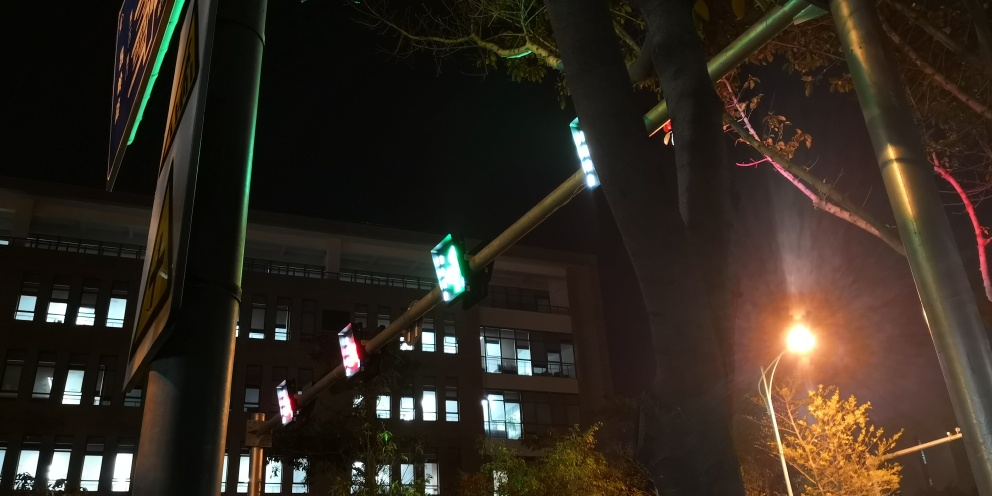Can you describe how the interplay of light and shadow contributes to the composition of this photograph? The interplay of light and shadow in this photo creates a striking contrast that draws the eye and adds depth to the composition. The bright areas illuminated by artificial lights stand out against the darker background, highlighting certain elements such as the traffic signals. Shadows cast by trees and other objects imbue the scene with a sense of mystery and can direct the viewer's attention to specific areas, while also emphasizing the time of day and urban setting. 